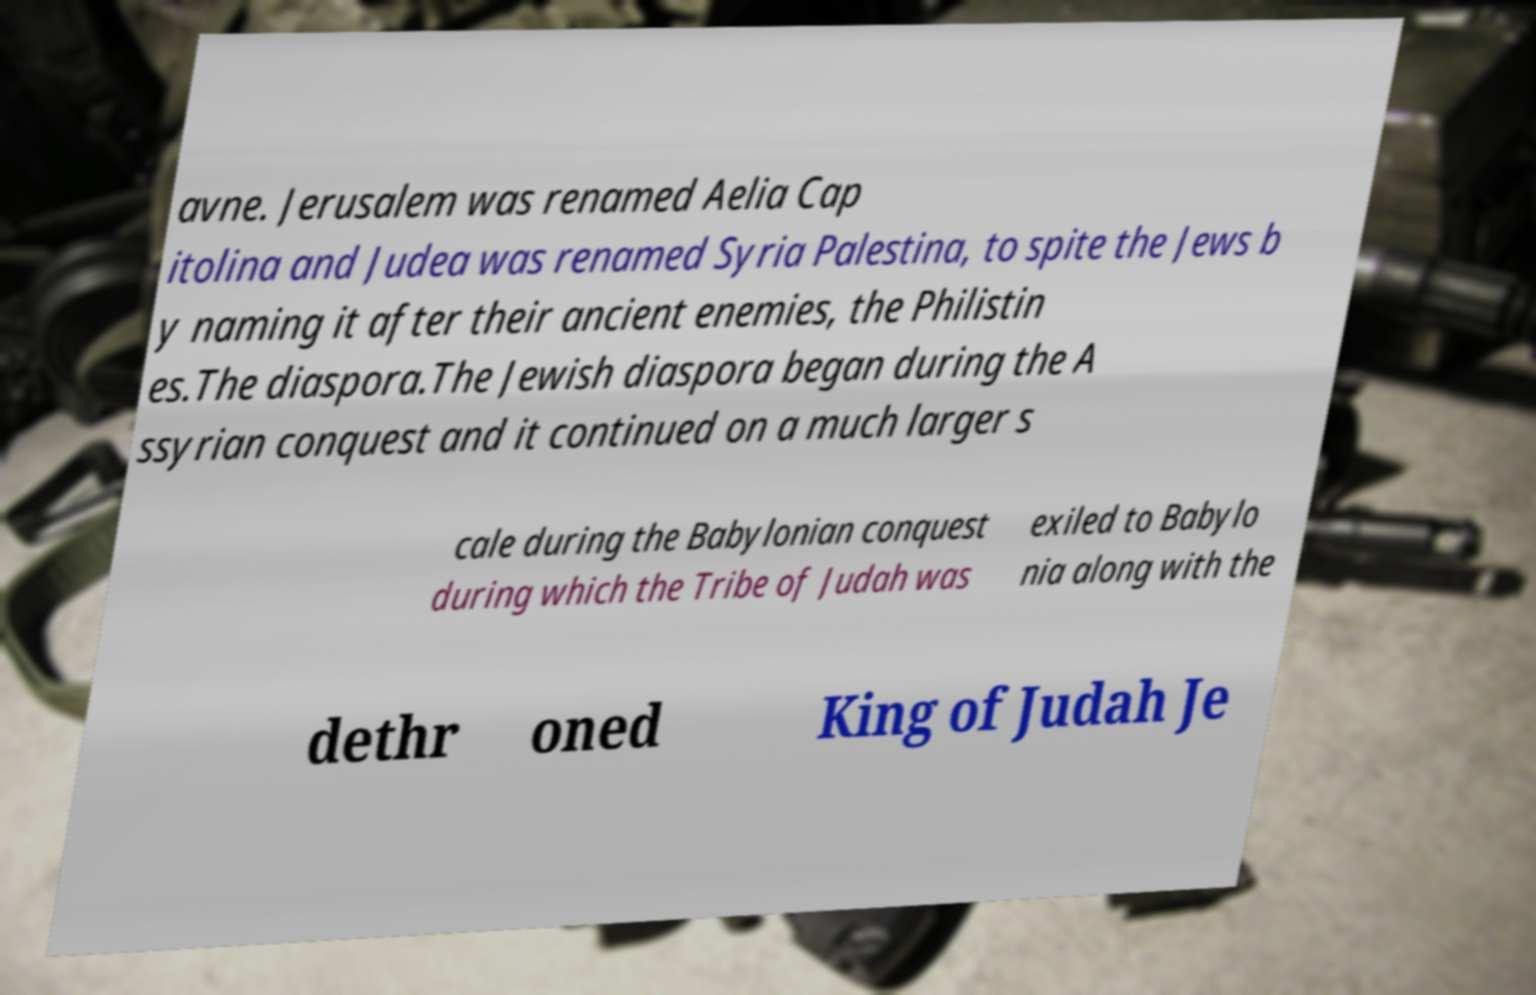Could you extract and type out the text from this image? avne. Jerusalem was renamed Aelia Cap itolina and Judea was renamed Syria Palestina, to spite the Jews b y naming it after their ancient enemies, the Philistin es.The diaspora.The Jewish diaspora began during the A ssyrian conquest and it continued on a much larger s cale during the Babylonian conquest during which the Tribe of Judah was exiled to Babylo nia along with the dethr oned King of Judah Je 